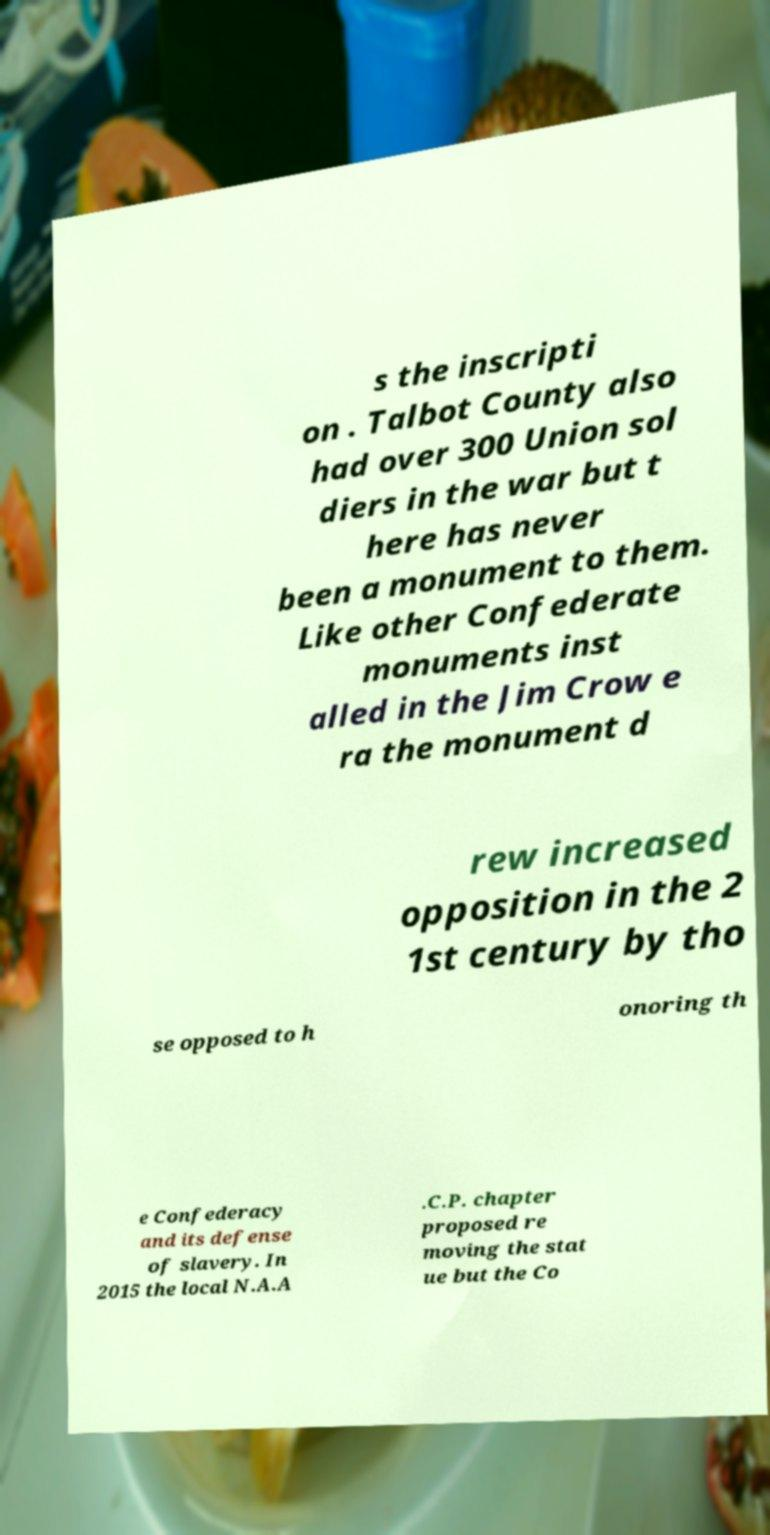Can you accurately transcribe the text from the provided image for me? s the inscripti on . Talbot County also had over 300 Union sol diers in the war but t here has never been a monument to them. Like other Confederate monuments inst alled in the Jim Crow e ra the monument d rew increased opposition in the 2 1st century by tho se opposed to h onoring th e Confederacy and its defense of slavery. In 2015 the local N.A.A .C.P. chapter proposed re moving the stat ue but the Co 